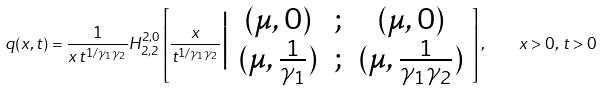Convert formula to latex. <formula><loc_0><loc_0><loc_500><loc_500>q ( x , t ) = \frac { 1 } { x \, t ^ { 1 / \gamma _ { 1 } \gamma _ { 2 } } } H ^ { 2 , 0 } _ { 2 , 2 } \left [ \frac { x } { t ^ { 1 / \gamma _ { 1 } \gamma _ { 2 } } } \Big | \begin{array} { c c c } ( \mu , 0 ) & ; & ( \mu , 0 ) \\ ( \mu , \frac { 1 } { \gamma _ { 1 } } ) & ; & ( \mu , \frac { 1 } { \gamma _ { 1 } \gamma _ { 2 } } ) \end{array} \right ] , \quad x > 0 , \, t > 0</formula> 